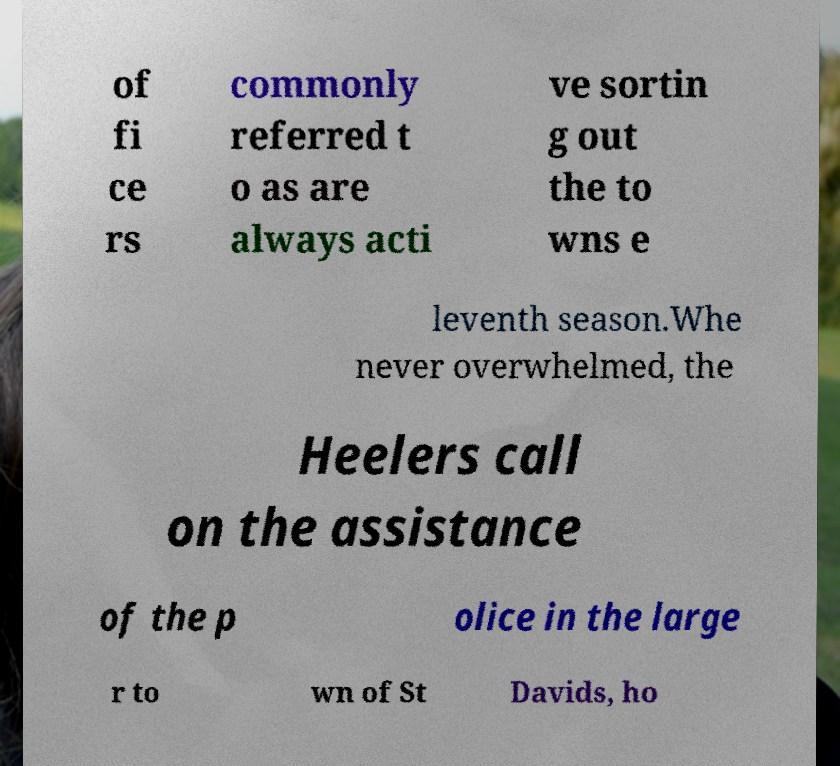For documentation purposes, I need the text within this image transcribed. Could you provide that? of fi ce rs commonly referred t o as are always acti ve sortin g out the to wns e leventh season.Whe never overwhelmed, the Heelers call on the assistance of the p olice in the large r to wn of St Davids, ho 